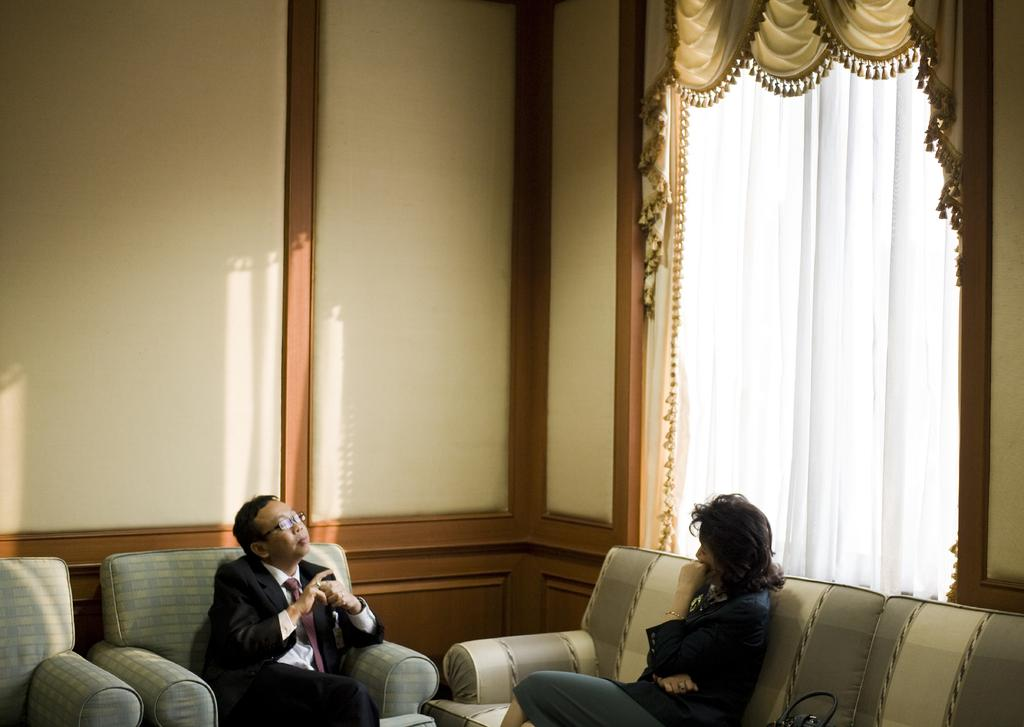How many people are present in the image? There are two persons in the image. What are the two persons doing in the image? The two persons are sitting on a sofa. What can be seen in the background of the image? There is a wall in the background of the image. Is there any window treatment present in the image? Yes, there is a curtain associated with the wall in the background. What type of spark can be seen coming from the chair in the image? There is no chair present in the image, and therefore no spark can be observed. 